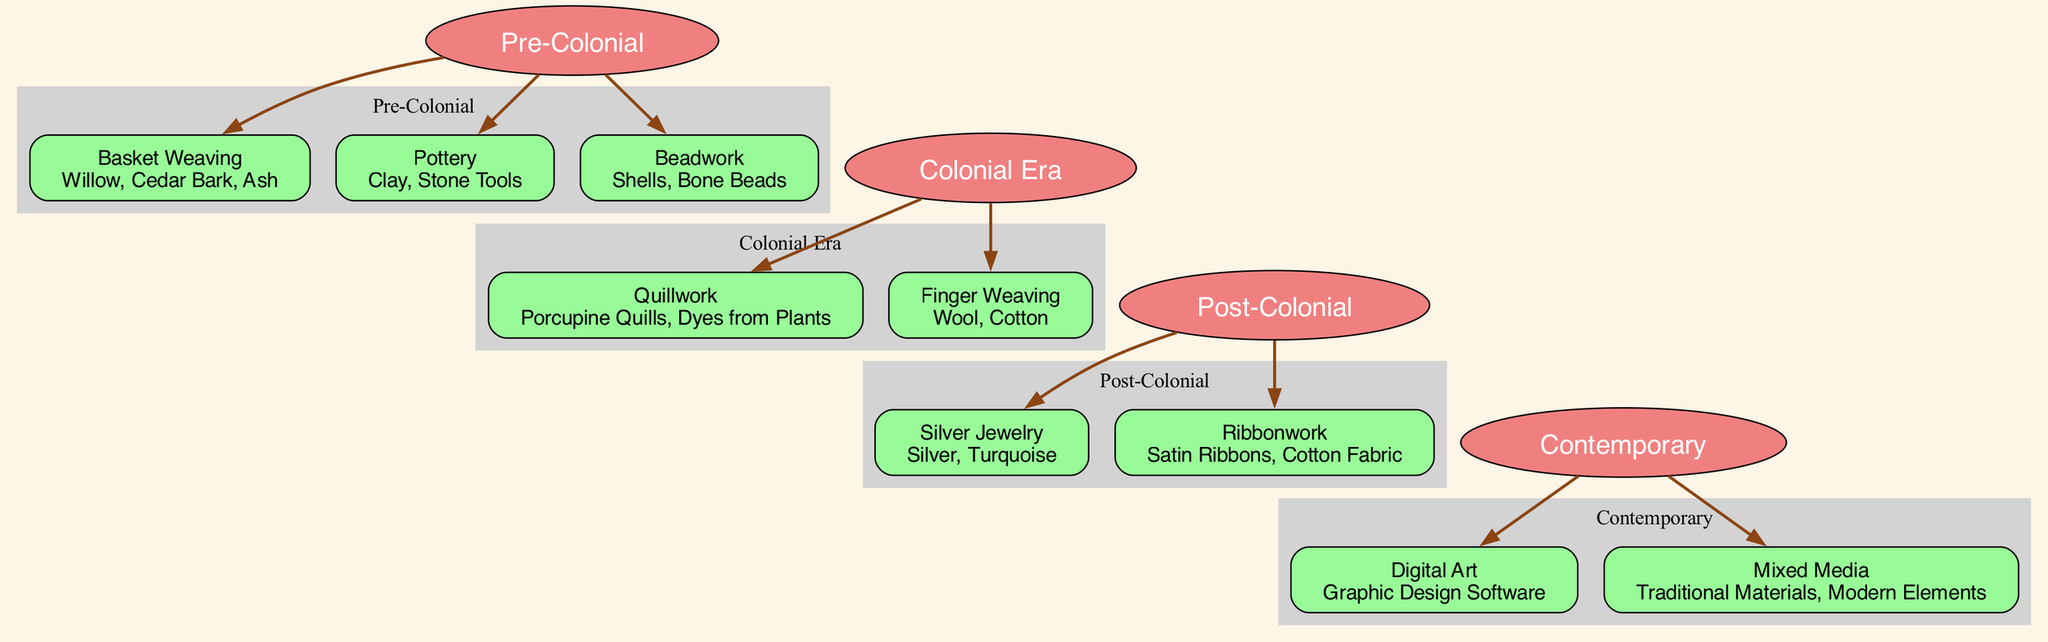What techniques are listed under the Colonial Era? The Colonial Era contains two techniques: Quillwork and Finger Weaving. These can be identified by locating the Colonial Era in the diagram and examining its associated techniques.
Answer: Quillwork, Finger Weaving How many generations are represented in the diagram? The generations listed in the diagram are Pre-Colonial, Colonial Era, Post-Colonial, and Contemporary, totaling four generations. Each generation is a distinct node in the family tree format of the diagram.
Answer: 4 What material is used for Digital Art? In the Contemporary generation, Digital Art is associated with Graphic Design Software as its material. This can be found by inspecting the techniques listed under the Contemporary generation in the diagram.
Answer: Graphic Design Software Which generation includes techniques that use Bone Beads? Bone Beads are mentioned in the Pre-Colonial generation under the technique Beadwork. Identifying this involves finding the Pre-Colonial node and recognizing the associated techniques that follow.
Answer: Pre-Colonial What do Silver Jewelry techniques include? The technique Silver Jewelry in the Post-Colonial generation includes Silver and Turquoise as the materials. This information is accessible by looking at Silver Jewelry under the Post-Colonial node in the diagram.
Answer: Silver, Turquoise What is the relationship between the Post-Colonial and Contemporary generations? The relationship between these two generations is a direct connection, as the arrows indicate the evolution of techniques from Post-Colonial to Contemporary. They are sequential in the timeline represented by the diagram.
Answer: Direct connection What is the first technique introduced in the family tree? The first technique introduced in the family tree is Basket Weaving, found in the Pre-Colonial generation. This can be identified as it is the first listed technique under the earliest generation in the diagram.
Answer: Basket Weaving How many techniques are shown under the Contemporary generation? There are two techniques listed under the Contemporary generation, specifically Digital Art and Mixed Media. This count can be verified by examining the techniques that follow the Contemporary generation node in the diagram.
Answer: 2 Which generation features techniques that utilize Satin Ribbons? Satin Ribbons are utilized in the technique Ribbonwork, which is found in the Post-Colonial generation. To confirm this, one needs to check the Post-Colonial techniques in the family tree structure of the diagram.
Answer: Post-Colonial 